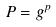Convert formula to latex. <formula><loc_0><loc_0><loc_500><loc_500>P = g ^ { p }</formula> 